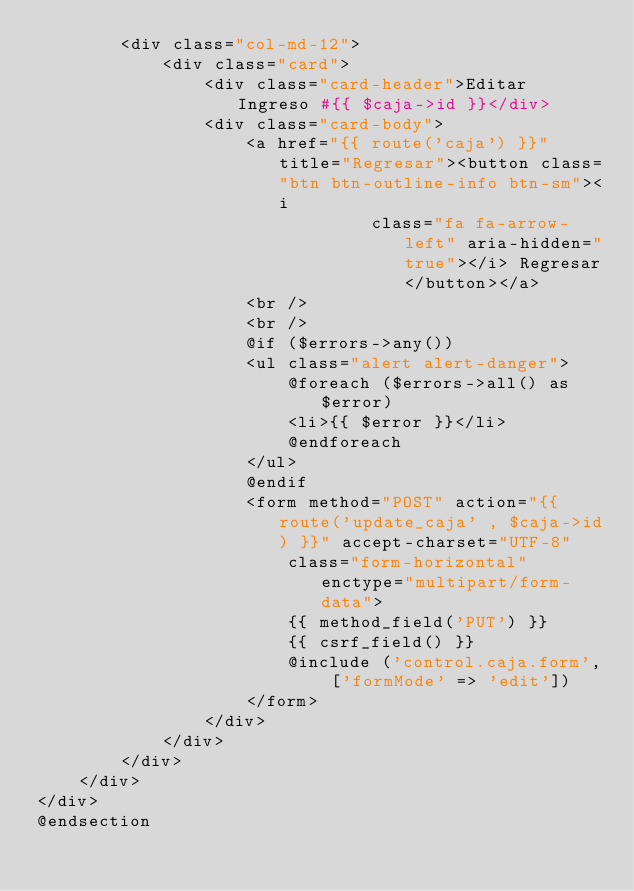<code> <loc_0><loc_0><loc_500><loc_500><_PHP_>        <div class="col-md-12">
            <div class="card">
                <div class="card-header">Editar Ingreso #{{ $caja->id }}</div>
                <div class="card-body">
                    <a href="{{ route('caja') }}" title="Regresar"><button class="btn btn-outline-info btn-sm"><i
                                class="fa fa-arrow-left" aria-hidden="true"></i> Regresar</button></a>
                    <br />
                    <br />
                    @if ($errors->any())
                    <ul class="alert alert-danger">
                        @foreach ($errors->all() as $error)
                        <li>{{ $error }}</li>
                        @endforeach
                    </ul>
                    @endif
                    <form method="POST" action="{{ route('update_caja' , $caja->id) }}" accept-charset="UTF-8"
                        class="form-horizontal" enctype="multipart/form-data">
                        {{ method_field('PUT') }}
                        {{ csrf_field() }}
                        @include ('control.caja.form', ['formMode' => 'edit'])
                    </form>
                </div>
            </div>
        </div>
    </div>
</div>
@endsection</code> 